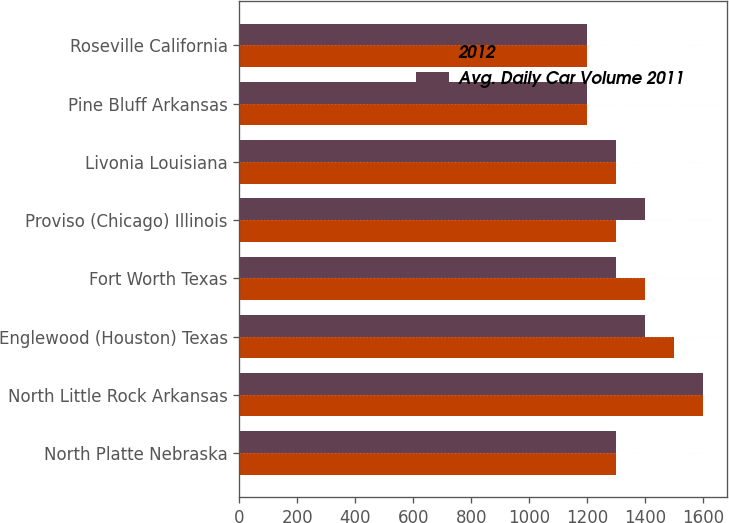Convert chart. <chart><loc_0><loc_0><loc_500><loc_500><stacked_bar_chart><ecel><fcel>North Platte Nebraska<fcel>North Little Rock Arkansas<fcel>Englewood (Houston) Texas<fcel>Fort Worth Texas<fcel>Proviso (Chicago) Illinois<fcel>Livonia Louisiana<fcel>Pine Bluff Arkansas<fcel>Roseville California<nl><fcel>2012<fcel>1300<fcel>1600<fcel>1500<fcel>1400<fcel>1300<fcel>1300<fcel>1200<fcel>1200<nl><fcel>Avg. Daily Car Volume 2011<fcel>1300<fcel>1600<fcel>1400<fcel>1300<fcel>1400<fcel>1300<fcel>1200<fcel>1200<nl></chart> 